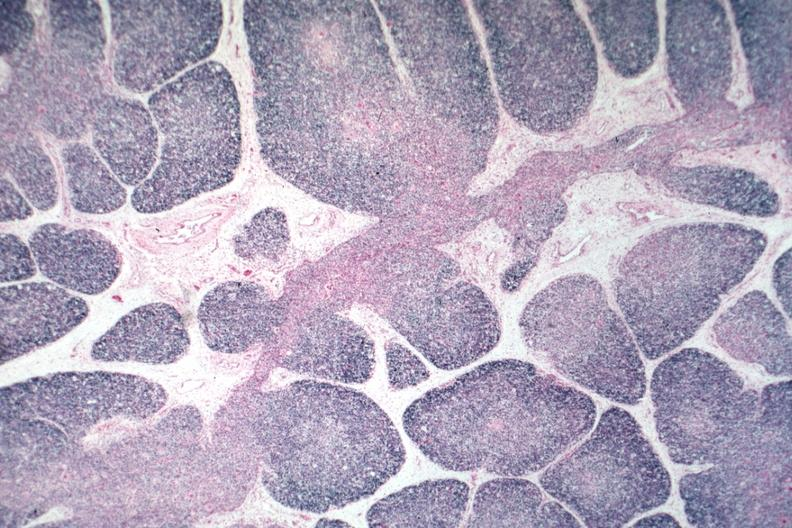s intraductal papillomatosis present?
Answer the question using a single word or phrase. No 